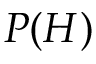<formula> <loc_0><loc_0><loc_500><loc_500>P ( H )</formula> 